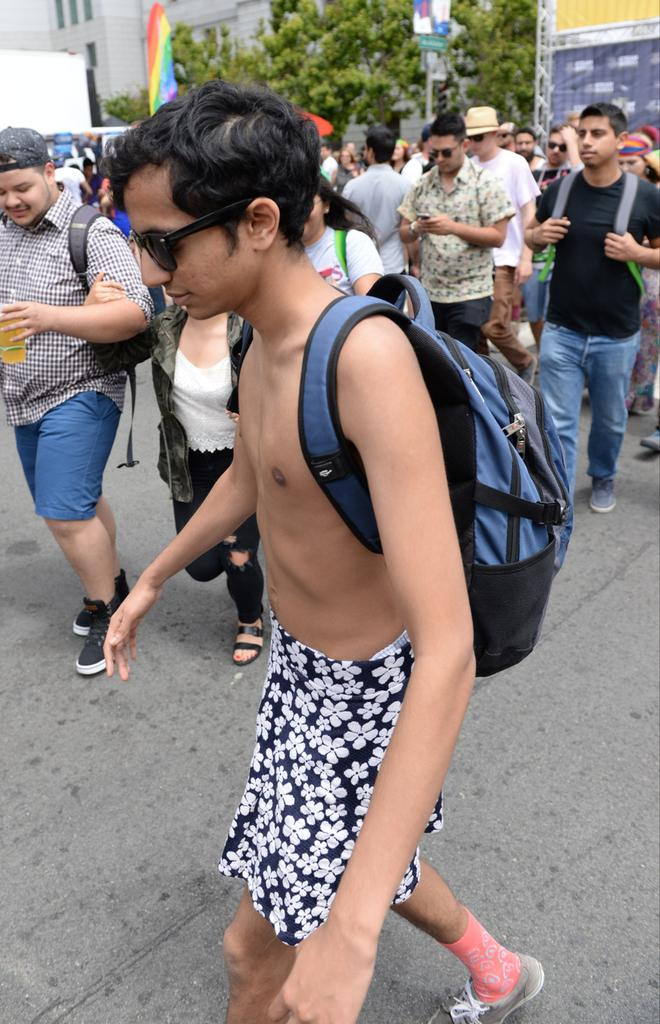What are the people in the image doing? The people in the image are walking on the road. What can be seen in the background of the image? In the background, there is a flag, boards on poles, trees, and a building. What type of knife is being used by the people walking on the road? There is no knife present in the image; the people are simply walking on the road. 